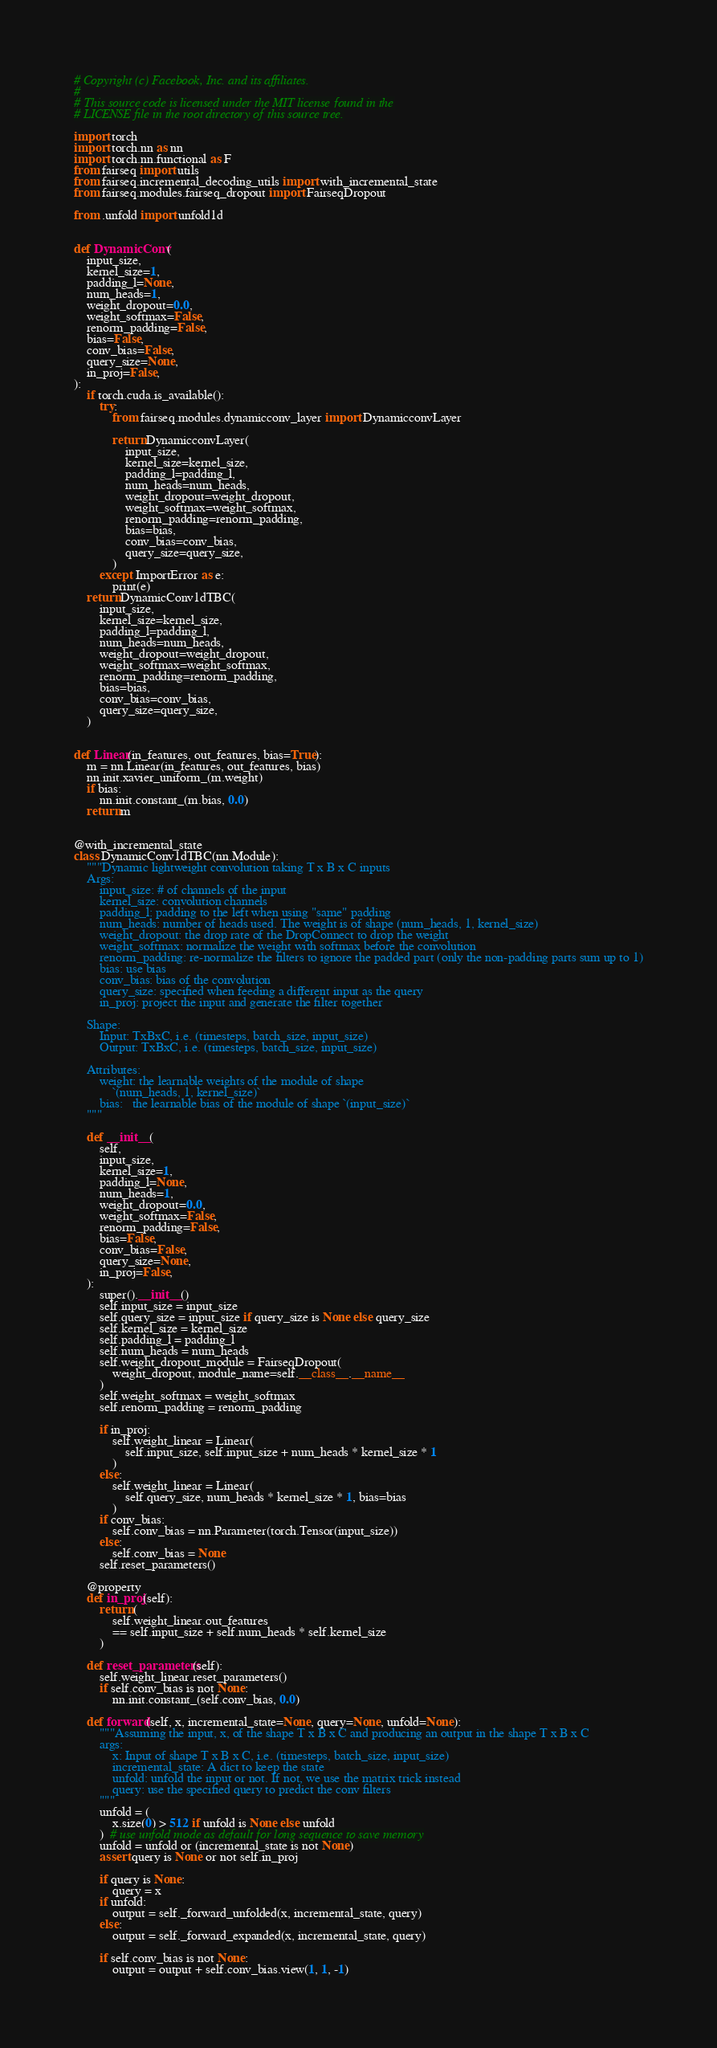<code> <loc_0><loc_0><loc_500><loc_500><_Python_># Copyright (c) Facebook, Inc. and its affiliates.
#
# This source code is licensed under the MIT license found in the
# LICENSE file in the root directory of this source tree.

import torch
import torch.nn as nn
import torch.nn.functional as F
from fairseq import utils
from fairseq.incremental_decoding_utils import with_incremental_state
from fairseq.modules.fairseq_dropout import FairseqDropout

from .unfold import unfold1d


def DynamicConv(
    input_size,
    kernel_size=1,
    padding_l=None,
    num_heads=1,
    weight_dropout=0.0,
    weight_softmax=False,
    renorm_padding=False,
    bias=False,
    conv_bias=False,
    query_size=None,
    in_proj=False,
):
    if torch.cuda.is_available():
        try:
            from fairseq.modules.dynamicconv_layer import DynamicconvLayer

            return DynamicconvLayer(
                input_size,
                kernel_size=kernel_size,
                padding_l=padding_l,
                num_heads=num_heads,
                weight_dropout=weight_dropout,
                weight_softmax=weight_softmax,
                renorm_padding=renorm_padding,
                bias=bias,
                conv_bias=conv_bias,
                query_size=query_size,
            )
        except ImportError as e:
            print(e)
    return DynamicConv1dTBC(
        input_size,
        kernel_size=kernel_size,
        padding_l=padding_l,
        num_heads=num_heads,
        weight_dropout=weight_dropout,
        weight_softmax=weight_softmax,
        renorm_padding=renorm_padding,
        bias=bias,
        conv_bias=conv_bias,
        query_size=query_size,
    )


def Linear(in_features, out_features, bias=True):
    m = nn.Linear(in_features, out_features, bias)
    nn.init.xavier_uniform_(m.weight)
    if bias:
        nn.init.constant_(m.bias, 0.0)
    return m


@with_incremental_state
class DynamicConv1dTBC(nn.Module):
    """Dynamic lightweight convolution taking T x B x C inputs
    Args:
        input_size: # of channels of the input
        kernel_size: convolution channels
        padding_l: padding to the left when using "same" padding
        num_heads: number of heads used. The weight is of shape (num_heads, 1, kernel_size)
        weight_dropout: the drop rate of the DropConnect to drop the weight
        weight_softmax: normalize the weight with softmax before the convolution
        renorm_padding: re-normalize the filters to ignore the padded part (only the non-padding parts sum up to 1)
        bias: use bias
        conv_bias: bias of the convolution
        query_size: specified when feeding a different input as the query
        in_proj: project the input and generate the filter together

    Shape:
        Input: TxBxC, i.e. (timesteps, batch_size, input_size)
        Output: TxBxC, i.e. (timesteps, batch_size, input_size)

    Attributes:
        weight: the learnable weights of the module of shape
            `(num_heads, 1, kernel_size)`
        bias:   the learnable bias of the module of shape `(input_size)`
    """

    def __init__(
        self,
        input_size,
        kernel_size=1,
        padding_l=None,
        num_heads=1,
        weight_dropout=0.0,
        weight_softmax=False,
        renorm_padding=False,
        bias=False,
        conv_bias=False,
        query_size=None,
        in_proj=False,
    ):
        super().__init__()
        self.input_size = input_size
        self.query_size = input_size if query_size is None else query_size
        self.kernel_size = kernel_size
        self.padding_l = padding_l
        self.num_heads = num_heads
        self.weight_dropout_module = FairseqDropout(
            weight_dropout, module_name=self.__class__.__name__
        )
        self.weight_softmax = weight_softmax
        self.renorm_padding = renorm_padding

        if in_proj:
            self.weight_linear = Linear(
                self.input_size, self.input_size + num_heads * kernel_size * 1
            )
        else:
            self.weight_linear = Linear(
                self.query_size, num_heads * kernel_size * 1, bias=bias
            )
        if conv_bias:
            self.conv_bias = nn.Parameter(torch.Tensor(input_size))
        else:
            self.conv_bias = None
        self.reset_parameters()

    @property
    def in_proj(self):
        return (
            self.weight_linear.out_features
            == self.input_size + self.num_heads * self.kernel_size
        )

    def reset_parameters(self):
        self.weight_linear.reset_parameters()
        if self.conv_bias is not None:
            nn.init.constant_(self.conv_bias, 0.0)

    def forward(self, x, incremental_state=None, query=None, unfold=None):
        """Assuming the input, x, of the shape T x B x C and producing an output in the shape T x B x C
        args:
            x: Input of shape T x B x C, i.e. (timesteps, batch_size, input_size)
            incremental_state: A dict to keep the state
            unfold: unfold the input or not. If not, we use the matrix trick instead
            query: use the specified query to predict the conv filters
        """
        unfold = (
            x.size(0) > 512 if unfold is None else unfold
        )  # use unfold mode as default for long sequence to save memory
        unfold = unfold or (incremental_state is not None)
        assert query is None or not self.in_proj

        if query is None:
            query = x
        if unfold:
            output = self._forward_unfolded(x, incremental_state, query)
        else:
            output = self._forward_expanded(x, incremental_state, query)

        if self.conv_bias is not None:
            output = output + self.conv_bias.view(1, 1, -1)</code> 